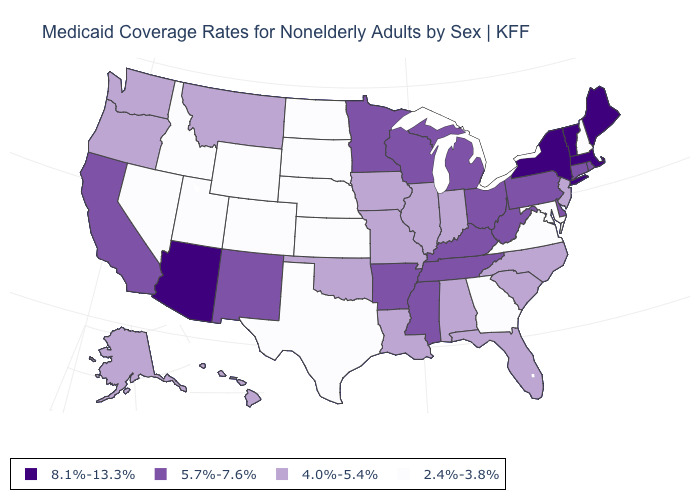Name the states that have a value in the range 2.4%-3.8%?
Be succinct. Colorado, Georgia, Idaho, Kansas, Maryland, Nebraska, Nevada, New Hampshire, North Dakota, South Dakota, Texas, Utah, Virginia, Wyoming. Is the legend a continuous bar?
Concise answer only. No. Which states have the highest value in the USA?
Write a very short answer. Arizona, Maine, Massachusetts, New York, Vermont. Among the states that border Nebraska , does Kansas have the highest value?
Quick response, please. No. Which states hav the highest value in the Northeast?
Short answer required. Maine, Massachusetts, New York, Vermont. Among the states that border Indiana , does Illinois have the lowest value?
Keep it brief. Yes. What is the lowest value in the USA?
Give a very brief answer. 2.4%-3.8%. Name the states that have a value in the range 8.1%-13.3%?
Answer briefly. Arizona, Maine, Massachusetts, New York, Vermont. Does Oklahoma have the lowest value in the South?
Quick response, please. No. Does Maryland have the same value as Georgia?
Answer briefly. Yes. Is the legend a continuous bar?
Write a very short answer. No. Does Pennsylvania have the lowest value in the Northeast?
Quick response, please. No. Does Washington have the lowest value in the West?
Give a very brief answer. No. Does the first symbol in the legend represent the smallest category?
Answer briefly. No. 